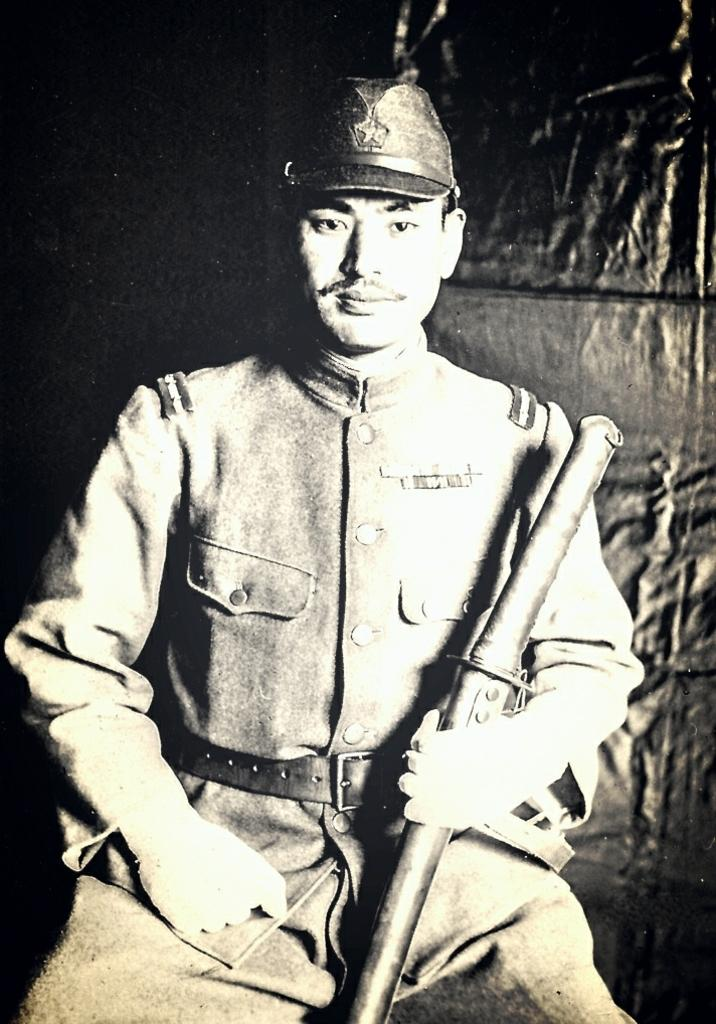What is the person in the image doing? The person is sitting in the image. What is the person holding in his hand? The person is holding a sword in his hand. What expression does the person have on his face? The person is smiling. What is the person wearing on his head? The person is wearing a cap on his head. What is the color scheme of the image? The image is black and white. What is the person's wealth status in the image? There is no information about the person's wealth status in the image. What journey is the person embarking on in the image? There is no indication of a journey in the image. 